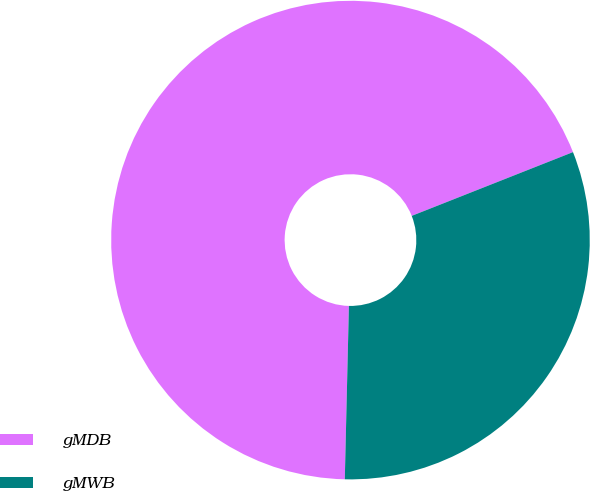<chart> <loc_0><loc_0><loc_500><loc_500><pie_chart><fcel>gMDB<fcel>gMWB<nl><fcel>68.63%<fcel>31.37%<nl></chart> 